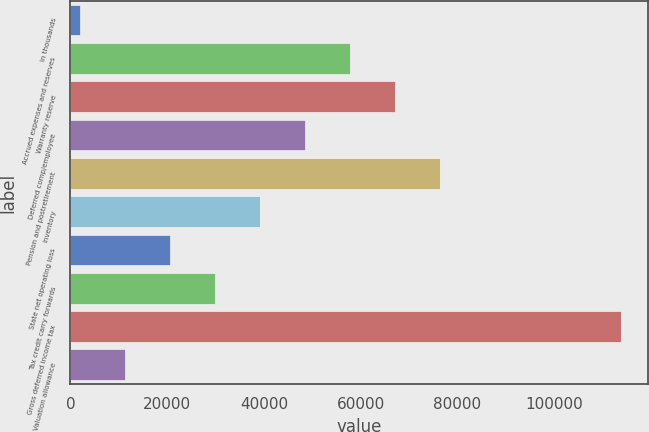<chart> <loc_0><loc_0><loc_500><loc_500><bar_chart><fcel>In thousands<fcel>Accrued expenses and reserves<fcel>Warranty reserve<fcel>Deferred comp/employee<fcel>Pension and postretirement<fcel>Inventory<fcel>State net operating loss<fcel>Tax credit carry forwards<fcel>Gross deferred income tax<fcel>Valuation allowance<nl><fcel>2010<fcel>57894.6<fcel>67208.7<fcel>48580.5<fcel>76522.8<fcel>39266.4<fcel>20638.2<fcel>29952.3<fcel>113779<fcel>11324.1<nl></chart> 